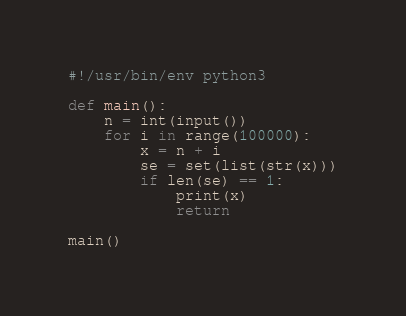<code> <loc_0><loc_0><loc_500><loc_500><_Python_>#!/usr/bin/env python3

def main():
    n = int(input())
    for i in range(100000):
        x = n + i
        se = set(list(str(x)))
        if len(se) == 1:
            print(x)
            return

main()
</code> 